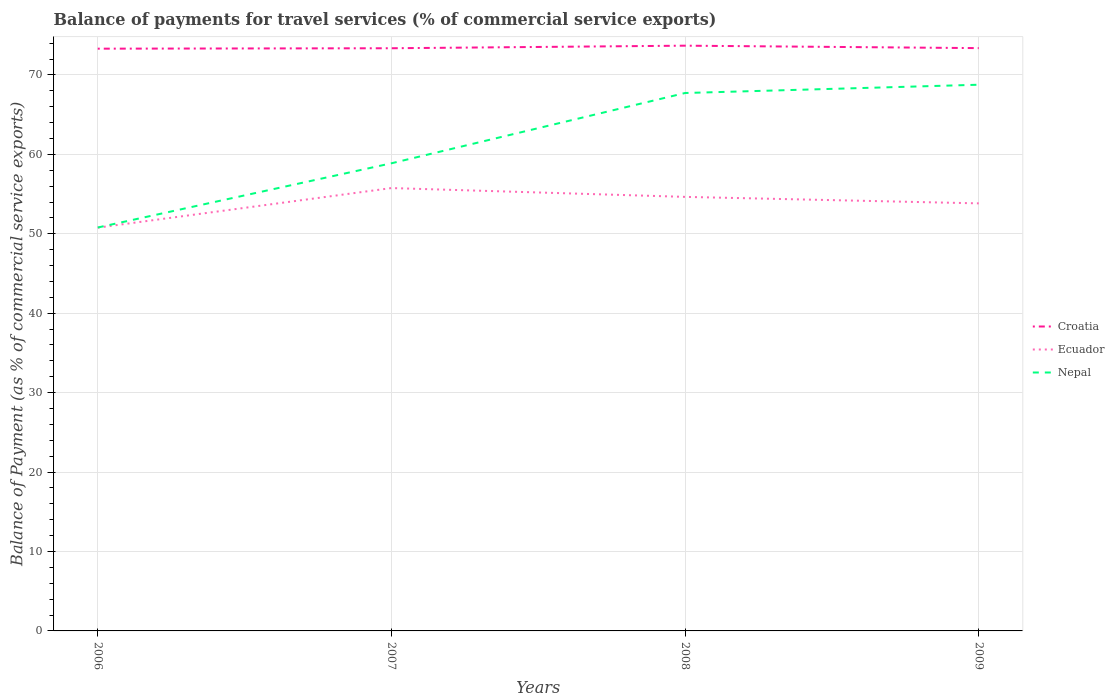Does the line corresponding to Croatia intersect with the line corresponding to Nepal?
Your answer should be very brief. No. Across all years, what is the maximum balance of payments for travel services in Nepal?
Keep it short and to the point. 50.79. What is the total balance of payments for travel services in Nepal in the graph?
Your answer should be compact. -17.98. What is the difference between the highest and the second highest balance of payments for travel services in Nepal?
Your answer should be compact. 17.98. How many years are there in the graph?
Offer a terse response. 4. Does the graph contain any zero values?
Keep it short and to the point. No. What is the title of the graph?
Provide a succinct answer. Balance of payments for travel services (% of commercial service exports). What is the label or title of the Y-axis?
Your answer should be compact. Balance of Payment (as % of commercial service exports). What is the Balance of Payment (as % of commercial service exports) in Croatia in 2006?
Your answer should be very brief. 73.31. What is the Balance of Payment (as % of commercial service exports) of Ecuador in 2006?
Ensure brevity in your answer.  50.78. What is the Balance of Payment (as % of commercial service exports) in Nepal in 2006?
Keep it short and to the point. 50.79. What is the Balance of Payment (as % of commercial service exports) of Croatia in 2007?
Keep it short and to the point. 73.36. What is the Balance of Payment (as % of commercial service exports) of Ecuador in 2007?
Offer a terse response. 55.76. What is the Balance of Payment (as % of commercial service exports) in Nepal in 2007?
Your answer should be compact. 58.88. What is the Balance of Payment (as % of commercial service exports) in Croatia in 2008?
Your answer should be compact. 73.69. What is the Balance of Payment (as % of commercial service exports) in Ecuador in 2008?
Your answer should be compact. 54.65. What is the Balance of Payment (as % of commercial service exports) of Nepal in 2008?
Provide a succinct answer. 67.73. What is the Balance of Payment (as % of commercial service exports) in Croatia in 2009?
Provide a succinct answer. 73.38. What is the Balance of Payment (as % of commercial service exports) of Ecuador in 2009?
Ensure brevity in your answer.  53.83. What is the Balance of Payment (as % of commercial service exports) in Nepal in 2009?
Your response must be concise. 68.77. Across all years, what is the maximum Balance of Payment (as % of commercial service exports) in Croatia?
Your answer should be very brief. 73.69. Across all years, what is the maximum Balance of Payment (as % of commercial service exports) of Ecuador?
Your answer should be very brief. 55.76. Across all years, what is the maximum Balance of Payment (as % of commercial service exports) in Nepal?
Make the answer very short. 68.77. Across all years, what is the minimum Balance of Payment (as % of commercial service exports) in Croatia?
Your response must be concise. 73.31. Across all years, what is the minimum Balance of Payment (as % of commercial service exports) of Ecuador?
Provide a short and direct response. 50.78. Across all years, what is the minimum Balance of Payment (as % of commercial service exports) of Nepal?
Offer a very short reply. 50.79. What is the total Balance of Payment (as % of commercial service exports) in Croatia in the graph?
Your answer should be compact. 293.74. What is the total Balance of Payment (as % of commercial service exports) in Ecuador in the graph?
Offer a terse response. 215.02. What is the total Balance of Payment (as % of commercial service exports) of Nepal in the graph?
Keep it short and to the point. 246.17. What is the difference between the Balance of Payment (as % of commercial service exports) of Croatia in 2006 and that in 2007?
Offer a very short reply. -0.05. What is the difference between the Balance of Payment (as % of commercial service exports) of Ecuador in 2006 and that in 2007?
Make the answer very short. -4.98. What is the difference between the Balance of Payment (as % of commercial service exports) in Nepal in 2006 and that in 2007?
Provide a succinct answer. -8.09. What is the difference between the Balance of Payment (as % of commercial service exports) in Croatia in 2006 and that in 2008?
Your answer should be very brief. -0.38. What is the difference between the Balance of Payment (as % of commercial service exports) of Ecuador in 2006 and that in 2008?
Your answer should be very brief. -3.87. What is the difference between the Balance of Payment (as % of commercial service exports) in Nepal in 2006 and that in 2008?
Offer a very short reply. -16.94. What is the difference between the Balance of Payment (as % of commercial service exports) of Croatia in 2006 and that in 2009?
Your answer should be compact. -0.07. What is the difference between the Balance of Payment (as % of commercial service exports) of Ecuador in 2006 and that in 2009?
Give a very brief answer. -3.06. What is the difference between the Balance of Payment (as % of commercial service exports) of Nepal in 2006 and that in 2009?
Ensure brevity in your answer.  -17.98. What is the difference between the Balance of Payment (as % of commercial service exports) of Croatia in 2007 and that in 2008?
Keep it short and to the point. -0.32. What is the difference between the Balance of Payment (as % of commercial service exports) in Ecuador in 2007 and that in 2008?
Give a very brief answer. 1.11. What is the difference between the Balance of Payment (as % of commercial service exports) in Nepal in 2007 and that in 2008?
Your answer should be compact. -8.85. What is the difference between the Balance of Payment (as % of commercial service exports) of Croatia in 2007 and that in 2009?
Your answer should be very brief. -0.02. What is the difference between the Balance of Payment (as % of commercial service exports) in Ecuador in 2007 and that in 2009?
Your answer should be very brief. 1.93. What is the difference between the Balance of Payment (as % of commercial service exports) in Nepal in 2007 and that in 2009?
Your answer should be compact. -9.89. What is the difference between the Balance of Payment (as % of commercial service exports) of Croatia in 2008 and that in 2009?
Offer a very short reply. 0.31. What is the difference between the Balance of Payment (as % of commercial service exports) in Ecuador in 2008 and that in 2009?
Keep it short and to the point. 0.82. What is the difference between the Balance of Payment (as % of commercial service exports) of Nepal in 2008 and that in 2009?
Make the answer very short. -1.04. What is the difference between the Balance of Payment (as % of commercial service exports) in Croatia in 2006 and the Balance of Payment (as % of commercial service exports) in Ecuador in 2007?
Offer a very short reply. 17.55. What is the difference between the Balance of Payment (as % of commercial service exports) in Croatia in 2006 and the Balance of Payment (as % of commercial service exports) in Nepal in 2007?
Your answer should be very brief. 14.43. What is the difference between the Balance of Payment (as % of commercial service exports) of Ecuador in 2006 and the Balance of Payment (as % of commercial service exports) of Nepal in 2007?
Offer a terse response. -8.1. What is the difference between the Balance of Payment (as % of commercial service exports) of Croatia in 2006 and the Balance of Payment (as % of commercial service exports) of Ecuador in 2008?
Make the answer very short. 18.66. What is the difference between the Balance of Payment (as % of commercial service exports) in Croatia in 2006 and the Balance of Payment (as % of commercial service exports) in Nepal in 2008?
Provide a succinct answer. 5.58. What is the difference between the Balance of Payment (as % of commercial service exports) of Ecuador in 2006 and the Balance of Payment (as % of commercial service exports) of Nepal in 2008?
Your answer should be very brief. -16.95. What is the difference between the Balance of Payment (as % of commercial service exports) in Croatia in 2006 and the Balance of Payment (as % of commercial service exports) in Ecuador in 2009?
Ensure brevity in your answer.  19.48. What is the difference between the Balance of Payment (as % of commercial service exports) in Croatia in 2006 and the Balance of Payment (as % of commercial service exports) in Nepal in 2009?
Your response must be concise. 4.54. What is the difference between the Balance of Payment (as % of commercial service exports) of Ecuador in 2006 and the Balance of Payment (as % of commercial service exports) of Nepal in 2009?
Your answer should be very brief. -17.99. What is the difference between the Balance of Payment (as % of commercial service exports) in Croatia in 2007 and the Balance of Payment (as % of commercial service exports) in Ecuador in 2008?
Provide a succinct answer. 18.71. What is the difference between the Balance of Payment (as % of commercial service exports) in Croatia in 2007 and the Balance of Payment (as % of commercial service exports) in Nepal in 2008?
Give a very brief answer. 5.64. What is the difference between the Balance of Payment (as % of commercial service exports) of Ecuador in 2007 and the Balance of Payment (as % of commercial service exports) of Nepal in 2008?
Your response must be concise. -11.97. What is the difference between the Balance of Payment (as % of commercial service exports) of Croatia in 2007 and the Balance of Payment (as % of commercial service exports) of Ecuador in 2009?
Make the answer very short. 19.53. What is the difference between the Balance of Payment (as % of commercial service exports) in Croatia in 2007 and the Balance of Payment (as % of commercial service exports) in Nepal in 2009?
Offer a terse response. 4.59. What is the difference between the Balance of Payment (as % of commercial service exports) of Ecuador in 2007 and the Balance of Payment (as % of commercial service exports) of Nepal in 2009?
Make the answer very short. -13.01. What is the difference between the Balance of Payment (as % of commercial service exports) of Croatia in 2008 and the Balance of Payment (as % of commercial service exports) of Ecuador in 2009?
Your answer should be compact. 19.85. What is the difference between the Balance of Payment (as % of commercial service exports) in Croatia in 2008 and the Balance of Payment (as % of commercial service exports) in Nepal in 2009?
Your response must be concise. 4.92. What is the difference between the Balance of Payment (as % of commercial service exports) in Ecuador in 2008 and the Balance of Payment (as % of commercial service exports) in Nepal in 2009?
Provide a succinct answer. -14.12. What is the average Balance of Payment (as % of commercial service exports) in Croatia per year?
Make the answer very short. 73.43. What is the average Balance of Payment (as % of commercial service exports) of Ecuador per year?
Ensure brevity in your answer.  53.75. What is the average Balance of Payment (as % of commercial service exports) of Nepal per year?
Your answer should be very brief. 61.54. In the year 2006, what is the difference between the Balance of Payment (as % of commercial service exports) of Croatia and Balance of Payment (as % of commercial service exports) of Ecuador?
Ensure brevity in your answer.  22.53. In the year 2006, what is the difference between the Balance of Payment (as % of commercial service exports) of Croatia and Balance of Payment (as % of commercial service exports) of Nepal?
Keep it short and to the point. 22.52. In the year 2006, what is the difference between the Balance of Payment (as % of commercial service exports) in Ecuador and Balance of Payment (as % of commercial service exports) in Nepal?
Give a very brief answer. -0.02. In the year 2007, what is the difference between the Balance of Payment (as % of commercial service exports) in Croatia and Balance of Payment (as % of commercial service exports) in Ecuador?
Give a very brief answer. 17.6. In the year 2007, what is the difference between the Balance of Payment (as % of commercial service exports) in Croatia and Balance of Payment (as % of commercial service exports) in Nepal?
Your answer should be compact. 14.48. In the year 2007, what is the difference between the Balance of Payment (as % of commercial service exports) of Ecuador and Balance of Payment (as % of commercial service exports) of Nepal?
Offer a very short reply. -3.12. In the year 2008, what is the difference between the Balance of Payment (as % of commercial service exports) in Croatia and Balance of Payment (as % of commercial service exports) in Ecuador?
Provide a succinct answer. 19.04. In the year 2008, what is the difference between the Balance of Payment (as % of commercial service exports) in Croatia and Balance of Payment (as % of commercial service exports) in Nepal?
Your response must be concise. 5.96. In the year 2008, what is the difference between the Balance of Payment (as % of commercial service exports) of Ecuador and Balance of Payment (as % of commercial service exports) of Nepal?
Make the answer very short. -13.08. In the year 2009, what is the difference between the Balance of Payment (as % of commercial service exports) of Croatia and Balance of Payment (as % of commercial service exports) of Ecuador?
Your answer should be compact. 19.55. In the year 2009, what is the difference between the Balance of Payment (as % of commercial service exports) in Croatia and Balance of Payment (as % of commercial service exports) in Nepal?
Your answer should be very brief. 4.61. In the year 2009, what is the difference between the Balance of Payment (as % of commercial service exports) in Ecuador and Balance of Payment (as % of commercial service exports) in Nepal?
Offer a very short reply. -14.94. What is the ratio of the Balance of Payment (as % of commercial service exports) in Ecuador in 2006 to that in 2007?
Your response must be concise. 0.91. What is the ratio of the Balance of Payment (as % of commercial service exports) in Nepal in 2006 to that in 2007?
Provide a succinct answer. 0.86. What is the ratio of the Balance of Payment (as % of commercial service exports) of Croatia in 2006 to that in 2008?
Your answer should be compact. 0.99. What is the ratio of the Balance of Payment (as % of commercial service exports) in Ecuador in 2006 to that in 2008?
Provide a short and direct response. 0.93. What is the ratio of the Balance of Payment (as % of commercial service exports) in Nepal in 2006 to that in 2008?
Provide a succinct answer. 0.75. What is the ratio of the Balance of Payment (as % of commercial service exports) in Ecuador in 2006 to that in 2009?
Provide a succinct answer. 0.94. What is the ratio of the Balance of Payment (as % of commercial service exports) of Nepal in 2006 to that in 2009?
Your response must be concise. 0.74. What is the ratio of the Balance of Payment (as % of commercial service exports) of Ecuador in 2007 to that in 2008?
Ensure brevity in your answer.  1.02. What is the ratio of the Balance of Payment (as % of commercial service exports) in Nepal in 2007 to that in 2008?
Provide a succinct answer. 0.87. What is the ratio of the Balance of Payment (as % of commercial service exports) of Ecuador in 2007 to that in 2009?
Your answer should be very brief. 1.04. What is the ratio of the Balance of Payment (as % of commercial service exports) of Nepal in 2007 to that in 2009?
Give a very brief answer. 0.86. What is the ratio of the Balance of Payment (as % of commercial service exports) in Croatia in 2008 to that in 2009?
Offer a very short reply. 1. What is the ratio of the Balance of Payment (as % of commercial service exports) of Ecuador in 2008 to that in 2009?
Offer a very short reply. 1.02. What is the difference between the highest and the second highest Balance of Payment (as % of commercial service exports) of Croatia?
Provide a succinct answer. 0.31. What is the difference between the highest and the second highest Balance of Payment (as % of commercial service exports) of Ecuador?
Ensure brevity in your answer.  1.11. What is the difference between the highest and the second highest Balance of Payment (as % of commercial service exports) of Nepal?
Your answer should be compact. 1.04. What is the difference between the highest and the lowest Balance of Payment (as % of commercial service exports) of Croatia?
Keep it short and to the point. 0.38. What is the difference between the highest and the lowest Balance of Payment (as % of commercial service exports) in Ecuador?
Ensure brevity in your answer.  4.98. What is the difference between the highest and the lowest Balance of Payment (as % of commercial service exports) of Nepal?
Offer a terse response. 17.98. 